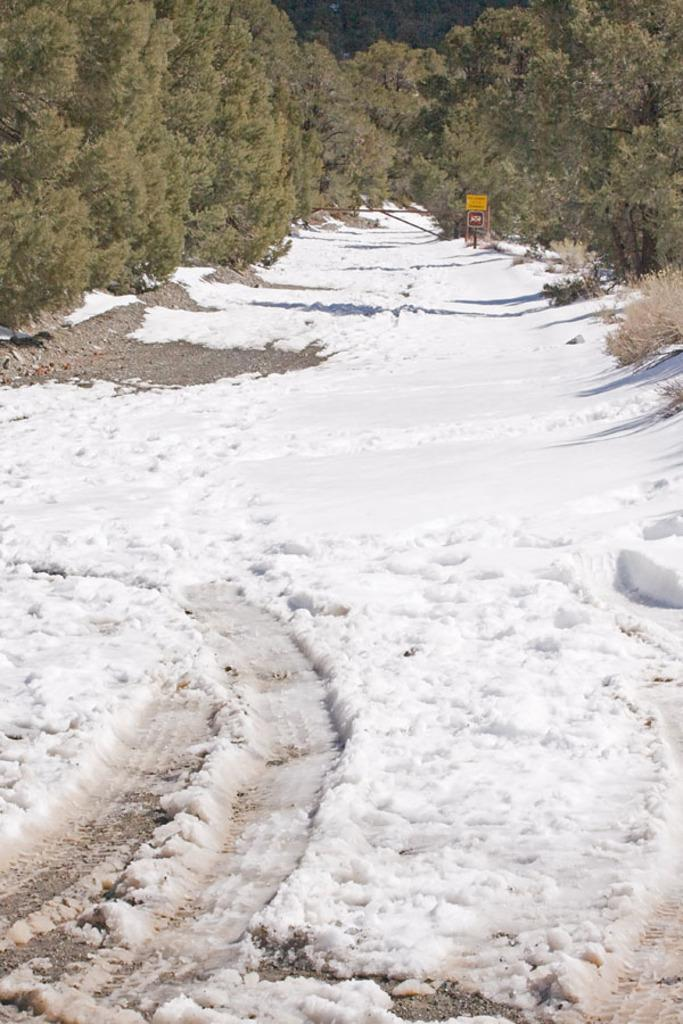What is the primary feature of the landscape in the image? There is snow in the image. What structure can be seen at the back of the image? There is a board at the back of the image. What type of natural elements are present in the image? There are trees in the image. How many clams can be seen in the image? There are no clams present in the image. What is the mass of the chickens in the image? There are no chickens present in the image, so their mass cannot be determined. 